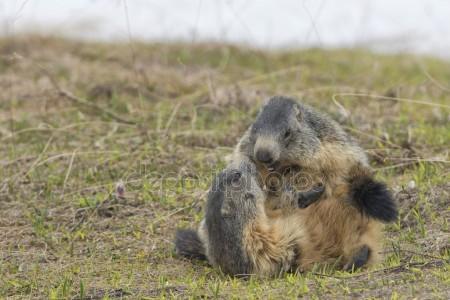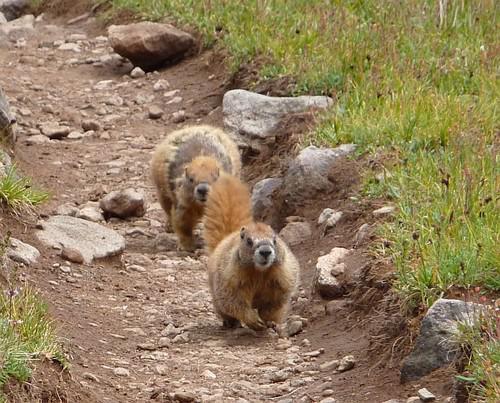The first image is the image on the left, the second image is the image on the right. Analyze the images presented: Is the assertion "Two animals in the image in the left are sitting face to face." valid? Answer yes or no. Yes. 